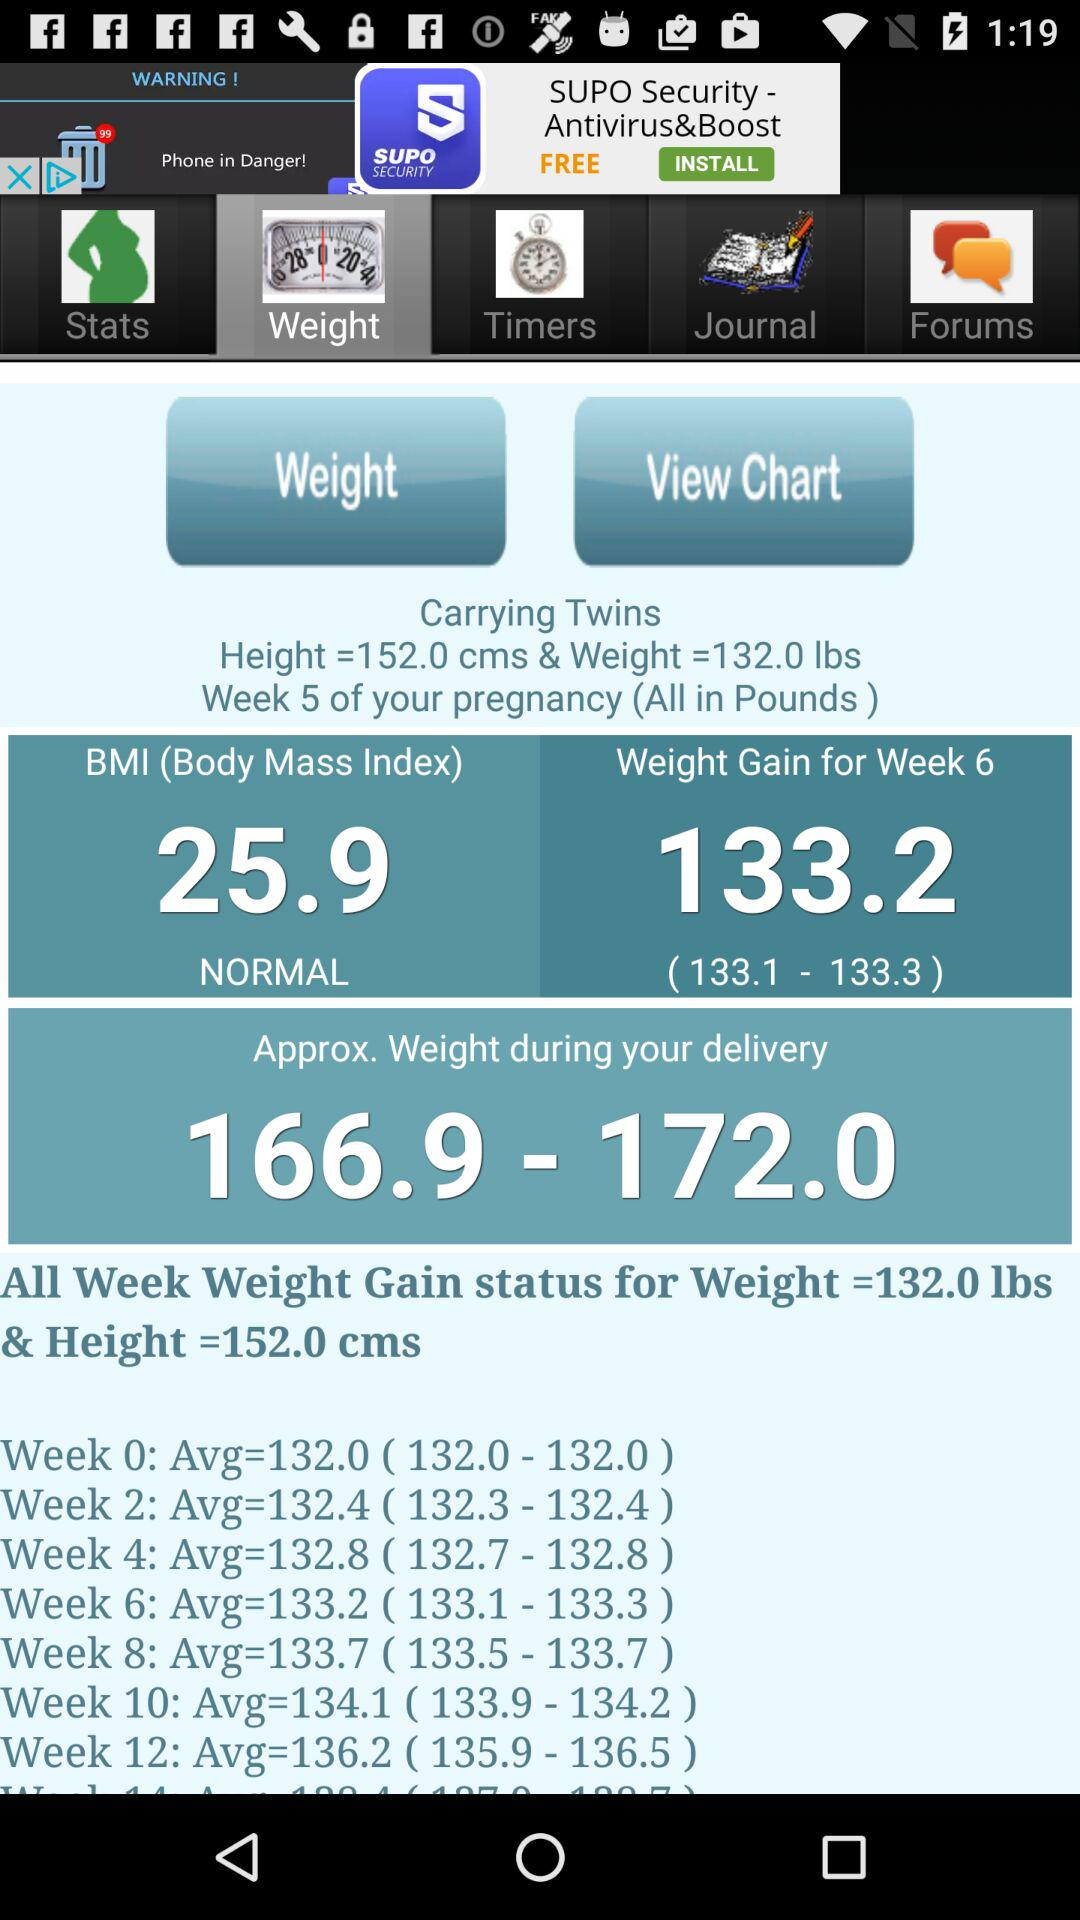What is the weight range for the baby during delivery?
Answer the question using a single word or phrase. 166.9-172.0 